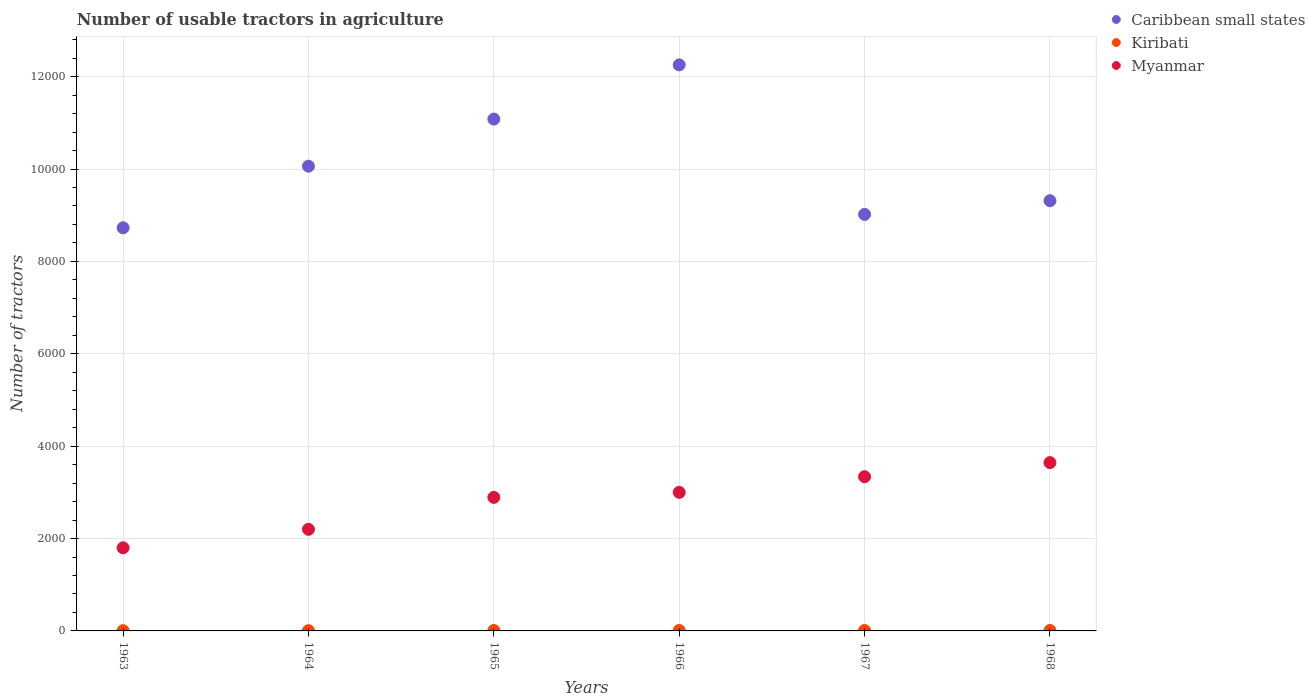Is the number of dotlines equal to the number of legend labels?
Give a very brief answer. Yes. What is the number of usable tractors in agriculture in Kiribati in 1968?
Keep it short and to the point. 10. Across all years, what is the maximum number of usable tractors in agriculture in Kiribati?
Your answer should be very brief. 10. Across all years, what is the minimum number of usable tractors in agriculture in Myanmar?
Your answer should be compact. 1800. In which year was the number of usable tractors in agriculture in Kiribati maximum?
Keep it short and to the point. 1965. What is the total number of usable tractors in agriculture in Myanmar in the graph?
Make the answer very short. 1.69e+04. What is the difference between the number of usable tractors in agriculture in Caribbean small states in 1963 and that in 1965?
Make the answer very short. -2353. What is the difference between the number of usable tractors in agriculture in Myanmar in 1968 and the number of usable tractors in agriculture in Kiribati in 1963?
Provide a succinct answer. 3638. What is the average number of usable tractors in agriculture in Myanmar per year?
Ensure brevity in your answer.  2812.33. In the year 1963, what is the difference between the number of usable tractors in agriculture in Myanmar and number of usable tractors in agriculture in Caribbean small states?
Make the answer very short. -6928. In how many years, is the number of usable tractors in agriculture in Myanmar greater than 3200?
Provide a succinct answer. 2. What is the ratio of the number of usable tractors in agriculture in Myanmar in 1963 to that in 1968?
Give a very brief answer. 0.49. Is the difference between the number of usable tractors in agriculture in Myanmar in 1964 and 1965 greater than the difference between the number of usable tractors in agriculture in Caribbean small states in 1964 and 1965?
Offer a terse response. Yes. What is the difference between the highest and the second highest number of usable tractors in agriculture in Caribbean small states?
Provide a short and direct response. 1174. What is the difference between the highest and the lowest number of usable tractors in agriculture in Caribbean small states?
Make the answer very short. 3527. In how many years, is the number of usable tractors in agriculture in Myanmar greater than the average number of usable tractors in agriculture in Myanmar taken over all years?
Ensure brevity in your answer.  4. Is the sum of the number of usable tractors in agriculture in Myanmar in 1963 and 1967 greater than the maximum number of usable tractors in agriculture in Kiribati across all years?
Ensure brevity in your answer.  Yes. Is the number of usable tractors in agriculture in Caribbean small states strictly greater than the number of usable tractors in agriculture in Kiribati over the years?
Provide a succinct answer. Yes. Where does the legend appear in the graph?
Keep it short and to the point. Top right. What is the title of the graph?
Offer a terse response. Number of usable tractors in agriculture. What is the label or title of the Y-axis?
Offer a terse response. Number of tractors. What is the Number of tractors of Caribbean small states in 1963?
Ensure brevity in your answer.  8728. What is the Number of tractors in Kiribati in 1963?
Provide a succinct answer. 6. What is the Number of tractors of Myanmar in 1963?
Offer a very short reply. 1800. What is the Number of tractors of Caribbean small states in 1964?
Give a very brief answer. 1.01e+04. What is the Number of tractors in Myanmar in 1964?
Provide a succinct answer. 2200. What is the Number of tractors in Caribbean small states in 1965?
Your answer should be very brief. 1.11e+04. What is the Number of tractors of Kiribati in 1965?
Provide a short and direct response. 10. What is the Number of tractors of Myanmar in 1965?
Give a very brief answer. 2891. What is the Number of tractors of Caribbean small states in 1966?
Provide a succinct answer. 1.23e+04. What is the Number of tractors of Kiribati in 1966?
Provide a succinct answer. 10. What is the Number of tractors in Myanmar in 1966?
Offer a terse response. 3000. What is the Number of tractors of Caribbean small states in 1967?
Your answer should be very brief. 9018. What is the Number of tractors in Myanmar in 1967?
Offer a very short reply. 3339. What is the Number of tractors of Caribbean small states in 1968?
Your answer should be compact. 9314. What is the Number of tractors of Myanmar in 1968?
Offer a terse response. 3644. Across all years, what is the maximum Number of tractors of Caribbean small states?
Provide a succinct answer. 1.23e+04. Across all years, what is the maximum Number of tractors in Myanmar?
Provide a short and direct response. 3644. Across all years, what is the minimum Number of tractors in Caribbean small states?
Make the answer very short. 8728. Across all years, what is the minimum Number of tractors of Kiribati?
Offer a very short reply. 6. Across all years, what is the minimum Number of tractors in Myanmar?
Offer a very short reply. 1800. What is the total Number of tractors in Caribbean small states in the graph?
Offer a very short reply. 6.05e+04. What is the total Number of tractors in Myanmar in the graph?
Give a very brief answer. 1.69e+04. What is the difference between the Number of tractors in Caribbean small states in 1963 and that in 1964?
Provide a succinct answer. -1333. What is the difference between the Number of tractors in Myanmar in 1963 and that in 1964?
Your answer should be very brief. -400. What is the difference between the Number of tractors in Caribbean small states in 1963 and that in 1965?
Provide a succinct answer. -2353. What is the difference between the Number of tractors of Kiribati in 1963 and that in 1965?
Ensure brevity in your answer.  -4. What is the difference between the Number of tractors of Myanmar in 1963 and that in 1965?
Offer a very short reply. -1091. What is the difference between the Number of tractors of Caribbean small states in 1963 and that in 1966?
Your answer should be very brief. -3527. What is the difference between the Number of tractors of Myanmar in 1963 and that in 1966?
Provide a short and direct response. -1200. What is the difference between the Number of tractors of Caribbean small states in 1963 and that in 1967?
Provide a short and direct response. -290. What is the difference between the Number of tractors of Myanmar in 1963 and that in 1967?
Your response must be concise. -1539. What is the difference between the Number of tractors in Caribbean small states in 1963 and that in 1968?
Your answer should be compact. -586. What is the difference between the Number of tractors of Kiribati in 1963 and that in 1968?
Give a very brief answer. -4. What is the difference between the Number of tractors in Myanmar in 1963 and that in 1968?
Offer a very short reply. -1844. What is the difference between the Number of tractors of Caribbean small states in 1964 and that in 1965?
Your response must be concise. -1020. What is the difference between the Number of tractors in Myanmar in 1964 and that in 1965?
Your response must be concise. -691. What is the difference between the Number of tractors of Caribbean small states in 1964 and that in 1966?
Keep it short and to the point. -2194. What is the difference between the Number of tractors in Kiribati in 1964 and that in 1966?
Ensure brevity in your answer.  -4. What is the difference between the Number of tractors in Myanmar in 1964 and that in 1966?
Your response must be concise. -800. What is the difference between the Number of tractors of Caribbean small states in 1964 and that in 1967?
Give a very brief answer. 1043. What is the difference between the Number of tractors in Myanmar in 1964 and that in 1967?
Your answer should be compact. -1139. What is the difference between the Number of tractors in Caribbean small states in 1964 and that in 1968?
Make the answer very short. 747. What is the difference between the Number of tractors in Myanmar in 1964 and that in 1968?
Provide a succinct answer. -1444. What is the difference between the Number of tractors in Caribbean small states in 1965 and that in 1966?
Keep it short and to the point. -1174. What is the difference between the Number of tractors in Kiribati in 1965 and that in 1966?
Your answer should be compact. 0. What is the difference between the Number of tractors of Myanmar in 1965 and that in 1966?
Your response must be concise. -109. What is the difference between the Number of tractors in Caribbean small states in 1965 and that in 1967?
Your answer should be compact. 2063. What is the difference between the Number of tractors in Myanmar in 1965 and that in 1967?
Your answer should be very brief. -448. What is the difference between the Number of tractors of Caribbean small states in 1965 and that in 1968?
Your answer should be compact. 1767. What is the difference between the Number of tractors of Kiribati in 1965 and that in 1968?
Offer a terse response. 0. What is the difference between the Number of tractors in Myanmar in 1965 and that in 1968?
Your answer should be very brief. -753. What is the difference between the Number of tractors in Caribbean small states in 1966 and that in 1967?
Make the answer very short. 3237. What is the difference between the Number of tractors in Kiribati in 1966 and that in 1967?
Your response must be concise. 0. What is the difference between the Number of tractors of Myanmar in 1966 and that in 1967?
Your answer should be compact. -339. What is the difference between the Number of tractors of Caribbean small states in 1966 and that in 1968?
Your response must be concise. 2941. What is the difference between the Number of tractors of Kiribati in 1966 and that in 1968?
Ensure brevity in your answer.  0. What is the difference between the Number of tractors in Myanmar in 1966 and that in 1968?
Offer a very short reply. -644. What is the difference between the Number of tractors in Caribbean small states in 1967 and that in 1968?
Ensure brevity in your answer.  -296. What is the difference between the Number of tractors in Myanmar in 1967 and that in 1968?
Offer a very short reply. -305. What is the difference between the Number of tractors in Caribbean small states in 1963 and the Number of tractors in Kiribati in 1964?
Provide a short and direct response. 8722. What is the difference between the Number of tractors of Caribbean small states in 1963 and the Number of tractors of Myanmar in 1964?
Provide a succinct answer. 6528. What is the difference between the Number of tractors in Kiribati in 1963 and the Number of tractors in Myanmar in 1964?
Offer a terse response. -2194. What is the difference between the Number of tractors in Caribbean small states in 1963 and the Number of tractors in Kiribati in 1965?
Your answer should be very brief. 8718. What is the difference between the Number of tractors of Caribbean small states in 1963 and the Number of tractors of Myanmar in 1965?
Provide a short and direct response. 5837. What is the difference between the Number of tractors of Kiribati in 1963 and the Number of tractors of Myanmar in 1965?
Offer a terse response. -2885. What is the difference between the Number of tractors of Caribbean small states in 1963 and the Number of tractors of Kiribati in 1966?
Ensure brevity in your answer.  8718. What is the difference between the Number of tractors in Caribbean small states in 1963 and the Number of tractors in Myanmar in 1966?
Give a very brief answer. 5728. What is the difference between the Number of tractors of Kiribati in 1963 and the Number of tractors of Myanmar in 1966?
Ensure brevity in your answer.  -2994. What is the difference between the Number of tractors in Caribbean small states in 1963 and the Number of tractors in Kiribati in 1967?
Your response must be concise. 8718. What is the difference between the Number of tractors of Caribbean small states in 1963 and the Number of tractors of Myanmar in 1967?
Your answer should be very brief. 5389. What is the difference between the Number of tractors of Kiribati in 1963 and the Number of tractors of Myanmar in 1967?
Provide a short and direct response. -3333. What is the difference between the Number of tractors of Caribbean small states in 1963 and the Number of tractors of Kiribati in 1968?
Give a very brief answer. 8718. What is the difference between the Number of tractors in Caribbean small states in 1963 and the Number of tractors in Myanmar in 1968?
Your response must be concise. 5084. What is the difference between the Number of tractors of Kiribati in 1963 and the Number of tractors of Myanmar in 1968?
Provide a short and direct response. -3638. What is the difference between the Number of tractors of Caribbean small states in 1964 and the Number of tractors of Kiribati in 1965?
Keep it short and to the point. 1.01e+04. What is the difference between the Number of tractors of Caribbean small states in 1964 and the Number of tractors of Myanmar in 1965?
Keep it short and to the point. 7170. What is the difference between the Number of tractors in Kiribati in 1964 and the Number of tractors in Myanmar in 1965?
Make the answer very short. -2885. What is the difference between the Number of tractors in Caribbean small states in 1964 and the Number of tractors in Kiribati in 1966?
Give a very brief answer. 1.01e+04. What is the difference between the Number of tractors of Caribbean small states in 1964 and the Number of tractors of Myanmar in 1966?
Your answer should be very brief. 7061. What is the difference between the Number of tractors of Kiribati in 1964 and the Number of tractors of Myanmar in 1966?
Provide a succinct answer. -2994. What is the difference between the Number of tractors of Caribbean small states in 1964 and the Number of tractors of Kiribati in 1967?
Your response must be concise. 1.01e+04. What is the difference between the Number of tractors of Caribbean small states in 1964 and the Number of tractors of Myanmar in 1967?
Ensure brevity in your answer.  6722. What is the difference between the Number of tractors in Kiribati in 1964 and the Number of tractors in Myanmar in 1967?
Ensure brevity in your answer.  -3333. What is the difference between the Number of tractors of Caribbean small states in 1964 and the Number of tractors of Kiribati in 1968?
Provide a short and direct response. 1.01e+04. What is the difference between the Number of tractors of Caribbean small states in 1964 and the Number of tractors of Myanmar in 1968?
Your answer should be very brief. 6417. What is the difference between the Number of tractors in Kiribati in 1964 and the Number of tractors in Myanmar in 1968?
Your answer should be compact. -3638. What is the difference between the Number of tractors of Caribbean small states in 1965 and the Number of tractors of Kiribati in 1966?
Give a very brief answer. 1.11e+04. What is the difference between the Number of tractors in Caribbean small states in 1965 and the Number of tractors in Myanmar in 1966?
Provide a succinct answer. 8081. What is the difference between the Number of tractors in Kiribati in 1965 and the Number of tractors in Myanmar in 1966?
Offer a very short reply. -2990. What is the difference between the Number of tractors in Caribbean small states in 1965 and the Number of tractors in Kiribati in 1967?
Provide a short and direct response. 1.11e+04. What is the difference between the Number of tractors in Caribbean small states in 1965 and the Number of tractors in Myanmar in 1967?
Make the answer very short. 7742. What is the difference between the Number of tractors of Kiribati in 1965 and the Number of tractors of Myanmar in 1967?
Provide a succinct answer. -3329. What is the difference between the Number of tractors of Caribbean small states in 1965 and the Number of tractors of Kiribati in 1968?
Provide a succinct answer. 1.11e+04. What is the difference between the Number of tractors of Caribbean small states in 1965 and the Number of tractors of Myanmar in 1968?
Ensure brevity in your answer.  7437. What is the difference between the Number of tractors of Kiribati in 1965 and the Number of tractors of Myanmar in 1968?
Provide a succinct answer. -3634. What is the difference between the Number of tractors in Caribbean small states in 1966 and the Number of tractors in Kiribati in 1967?
Offer a terse response. 1.22e+04. What is the difference between the Number of tractors of Caribbean small states in 1966 and the Number of tractors of Myanmar in 1967?
Keep it short and to the point. 8916. What is the difference between the Number of tractors of Kiribati in 1966 and the Number of tractors of Myanmar in 1967?
Your answer should be compact. -3329. What is the difference between the Number of tractors of Caribbean small states in 1966 and the Number of tractors of Kiribati in 1968?
Make the answer very short. 1.22e+04. What is the difference between the Number of tractors of Caribbean small states in 1966 and the Number of tractors of Myanmar in 1968?
Ensure brevity in your answer.  8611. What is the difference between the Number of tractors in Kiribati in 1966 and the Number of tractors in Myanmar in 1968?
Your answer should be very brief. -3634. What is the difference between the Number of tractors of Caribbean small states in 1967 and the Number of tractors of Kiribati in 1968?
Ensure brevity in your answer.  9008. What is the difference between the Number of tractors in Caribbean small states in 1967 and the Number of tractors in Myanmar in 1968?
Make the answer very short. 5374. What is the difference between the Number of tractors of Kiribati in 1967 and the Number of tractors of Myanmar in 1968?
Offer a terse response. -3634. What is the average Number of tractors of Caribbean small states per year?
Make the answer very short. 1.01e+04. What is the average Number of tractors of Kiribati per year?
Your answer should be very brief. 8.67. What is the average Number of tractors of Myanmar per year?
Your response must be concise. 2812.33. In the year 1963, what is the difference between the Number of tractors of Caribbean small states and Number of tractors of Kiribati?
Your answer should be compact. 8722. In the year 1963, what is the difference between the Number of tractors in Caribbean small states and Number of tractors in Myanmar?
Ensure brevity in your answer.  6928. In the year 1963, what is the difference between the Number of tractors of Kiribati and Number of tractors of Myanmar?
Offer a terse response. -1794. In the year 1964, what is the difference between the Number of tractors of Caribbean small states and Number of tractors of Kiribati?
Give a very brief answer. 1.01e+04. In the year 1964, what is the difference between the Number of tractors of Caribbean small states and Number of tractors of Myanmar?
Ensure brevity in your answer.  7861. In the year 1964, what is the difference between the Number of tractors of Kiribati and Number of tractors of Myanmar?
Make the answer very short. -2194. In the year 1965, what is the difference between the Number of tractors in Caribbean small states and Number of tractors in Kiribati?
Offer a terse response. 1.11e+04. In the year 1965, what is the difference between the Number of tractors in Caribbean small states and Number of tractors in Myanmar?
Provide a succinct answer. 8190. In the year 1965, what is the difference between the Number of tractors of Kiribati and Number of tractors of Myanmar?
Your answer should be compact. -2881. In the year 1966, what is the difference between the Number of tractors of Caribbean small states and Number of tractors of Kiribati?
Give a very brief answer. 1.22e+04. In the year 1966, what is the difference between the Number of tractors in Caribbean small states and Number of tractors in Myanmar?
Your answer should be compact. 9255. In the year 1966, what is the difference between the Number of tractors in Kiribati and Number of tractors in Myanmar?
Keep it short and to the point. -2990. In the year 1967, what is the difference between the Number of tractors of Caribbean small states and Number of tractors of Kiribati?
Your response must be concise. 9008. In the year 1967, what is the difference between the Number of tractors of Caribbean small states and Number of tractors of Myanmar?
Provide a short and direct response. 5679. In the year 1967, what is the difference between the Number of tractors of Kiribati and Number of tractors of Myanmar?
Give a very brief answer. -3329. In the year 1968, what is the difference between the Number of tractors in Caribbean small states and Number of tractors in Kiribati?
Ensure brevity in your answer.  9304. In the year 1968, what is the difference between the Number of tractors of Caribbean small states and Number of tractors of Myanmar?
Your answer should be very brief. 5670. In the year 1968, what is the difference between the Number of tractors in Kiribati and Number of tractors in Myanmar?
Offer a very short reply. -3634. What is the ratio of the Number of tractors in Caribbean small states in 1963 to that in 1964?
Offer a terse response. 0.87. What is the ratio of the Number of tractors of Kiribati in 1963 to that in 1964?
Give a very brief answer. 1. What is the ratio of the Number of tractors of Myanmar in 1963 to that in 1964?
Offer a very short reply. 0.82. What is the ratio of the Number of tractors in Caribbean small states in 1963 to that in 1965?
Make the answer very short. 0.79. What is the ratio of the Number of tractors in Kiribati in 1963 to that in 1965?
Your answer should be very brief. 0.6. What is the ratio of the Number of tractors in Myanmar in 1963 to that in 1965?
Provide a succinct answer. 0.62. What is the ratio of the Number of tractors in Caribbean small states in 1963 to that in 1966?
Keep it short and to the point. 0.71. What is the ratio of the Number of tractors of Kiribati in 1963 to that in 1966?
Keep it short and to the point. 0.6. What is the ratio of the Number of tractors in Myanmar in 1963 to that in 1966?
Keep it short and to the point. 0.6. What is the ratio of the Number of tractors of Caribbean small states in 1963 to that in 1967?
Your answer should be compact. 0.97. What is the ratio of the Number of tractors of Myanmar in 1963 to that in 1967?
Your answer should be compact. 0.54. What is the ratio of the Number of tractors in Caribbean small states in 1963 to that in 1968?
Your answer should be compact. 0.94. What is the ratio of the Number of tractors in Myanmar in 1963 to that in 1968?
Offer a very short reply. 0.49. What is the ratio of the Number of tractors in Caribbean small states in 1964 to that in 1965?
Keep it short and to the point. 0.91. What is the ratio of the Number of tractors in Myanmar in 1964 to that in 1965?
Ensure brevity in your answer.  0.76. What is the ratio of the Number of tractors of Caribbean small states in 1964 to that in 1966?
Offer a very short reply. 0.82. What is the ratio of the Number of tractors of Kiribati in 1964 to that in 1966?
Your answer should be compact. 0.6. What is the ratio of the Number of tractors in Myanmar in 1964 to that in 1966?
Provide a short and direct response. 0.73. What is the ratio of the Number of tractors of Caribbean small states in 1964 to that in 1967?
Make the answer very short. 1.12. What is the ratio of the Number of tractors in Kiribati in 1964 to that in 1967?
Offer a terse response. 0.6. What is the ratio of the Number of tractors in Myanmar in 1964 to that in 1967?
Keep it short and to the point. 0.66. What is the ratio of the Number of tractors of Caribbean small states in 1964 to that in 1968?
Ensure brevity in your answer.  1.08. What is the ratio of the Number of tractors of Kiribati in 1964 to that in 1968?
Provide a succinct answer. 0.6. What is the ratio of the Number of tractors in Myanmar in 1964 to that in 1968?
Make the answer very short. 0.6. What is the ratio of the Number of tractors in Caribbean small states in 1965 to that in 1966?
Your answer should be very brief. 0.9. What is the ratio of the Number of tractors in Myanmar in 1965 to that in 1966?
Keep it short and to the point. 0.96. What is the ratio of the Number of tractors in Caribbean small states in 1965 to that in 1967?
Ensure brevity in your answer.  1.23. What is the ratio of the Number of tractors of Kiribati in 1965 to that in 1967?
Make the answer very short. 1. What is the ratio of the Number of tractors in Myanmar in 1965 to that in 1967?
Offer a terse response. 0.87. What is the ratio of the Number of tractors of Caribbean small states in 1965 to that in 1968?
Your answer should be very brief. 1.19. What is the ratio of the Number of tractors of Myanmar in 1965 to that in 1968?
Keep it short and to the point. 0.79. What is the ratio of the Number of tractors of Caribbean small states in 1966 to that in 1967?
Provide a succinct answer. 1.36. What is the ratio of the Number of tractors of Kiribati in 1966 to that in 1967?
Your answer should be compact. 1. What is the ratio of the Number of tractors of Myanmar in 1966 to that in 1967?
Offer a very short reply. 0.9. What is the ratio of the Number of tractors of Caribbean small states in 1966 to that in 1968?
Ensure brevity in your answer.  1.32. What is the ratio of the Number of tractors in Kiribati in 1966 to that in 1968?
Keep it short and to the point. 1. What is the ratio of the Number of tractors in Myanmar in 1966 to that in 1968?
Your answer should be very brief. 0.82. What is the ratio of the Number of tractors of Caribbean small states in 1967 to that in 1968?
Your response must be concise. 0.97. What is the ratio of the Number of tractors of Kiribati in 1967 to that in 1968?
Offer a terse response. 1. What is the ratio of the Number of tractors in Myanmar in 1967 to that in 1968?
Keep it short and to the point. 0.92. What is the difference between the highest and the second highest Number of tractors in Caribbean small states?
Make the answer very short. 1174. What is the difference between the highest and the second highest Number of tractors of Kiribati?
Ensure brevity in your answer.  0. What is the difference between the highest and the second highest Number of tractors in Myanmar?
Your answer should be very brief. 305. What is the difference between the highest and the lowest Number of tractors of Caribbean small states?
Offer a terse response. 3527. What is the difference between the highest and the lowest Number of tractors in Myanmar?
Provide a succinct answer. 1844. 